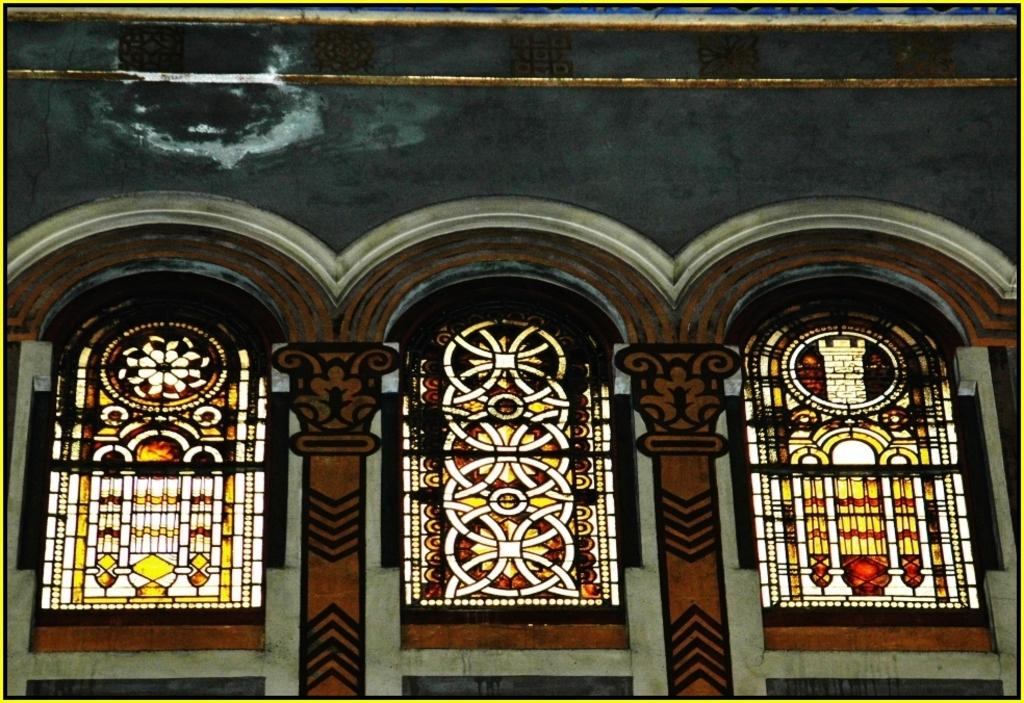What type of decoration is present on the wall in the image? There are painted glass windows on the wall in the image. What is the purpose of these painted glass windows? The painted glass windows may serve a decorative or artistic purpose, or they could be functional, providing light and privacy. What type of breakfast is being served in the image? There is no breakfast or any food visible in the image; it only features painted glass windows on the wall. 